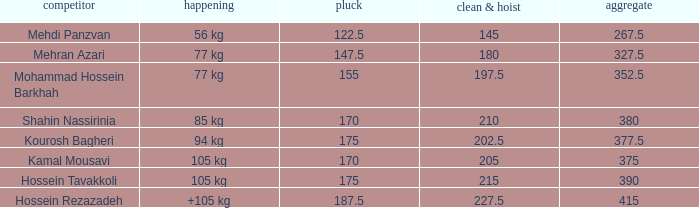How many snatches were there with a total of 267.5? 0.0. 